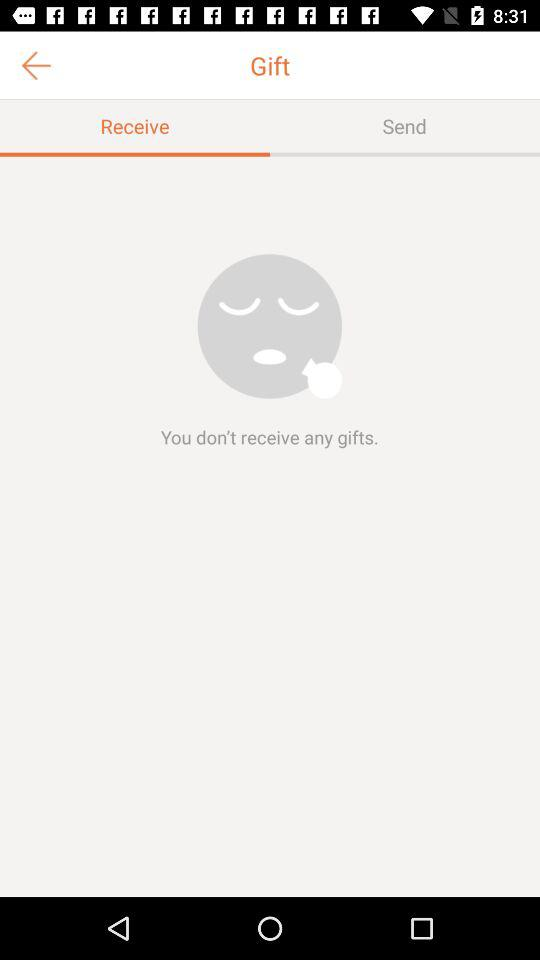How many gifts have I received?
Answer the question using a single word or phrase. 0 